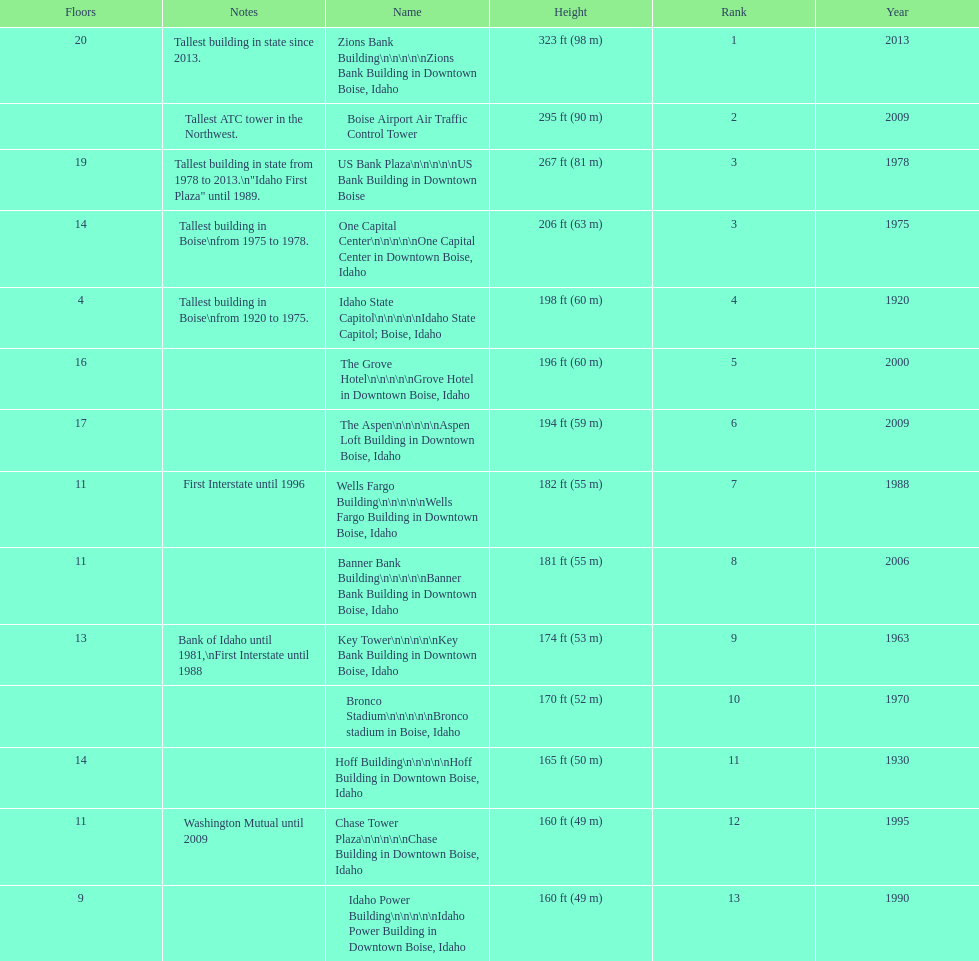What is the name of the last building on this chart? Idaho Power Building. 